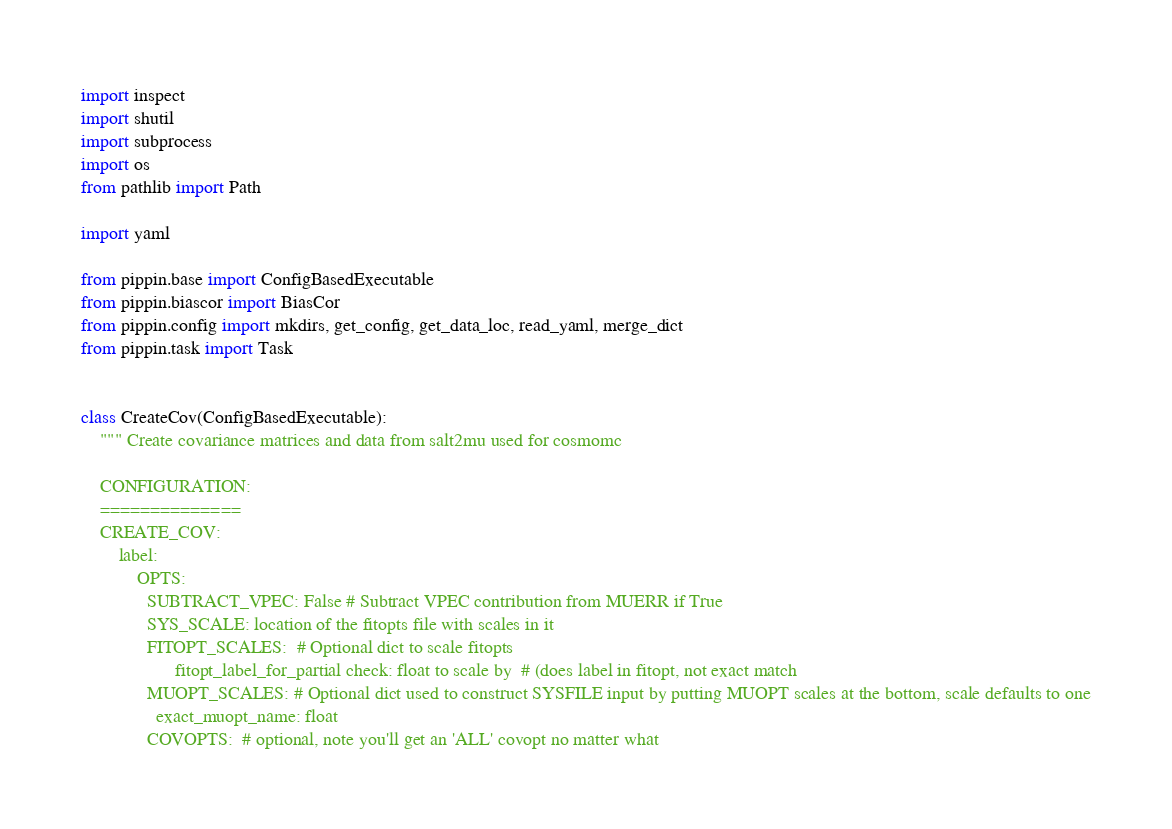<code> <loc_0><loc_0><loc_500><loc_500><_Python_>import inspect
import shutil
import subprocess
import os
from pathlib import Path

import yaml

from pippin.base import ConfigBasedExecutable
from pippin.biascor import BiasCor
from pippin.config import mkdirs, get_config, get_data_loc, read_yaml, merge_dict
from pippin.task import Task


class CreateCov(ConfigBasedExecutable):
    """ Create covariance matrices and data from salt2mu used for cosmomc

    CONFIGURATION:
    ==============
    CREATE_COV:
        label:
            OPTS:
              SUBTRACT_VPEC: False # Subtract VPEC contribution from MUERR if True
              SYS_SCALE: location of the fitopts file with scales in it
              FITOPT_SCALES:  # Optional dict to scale fitopts
                    fitopt_label_for_partial check: float to scale by  # (does label in fitopt, not exact match
              MUOPT_SCALES: # Optional dict used to construct SYSFILE input by putting MUOPT scales at the bottom, scale defaults to one
                exact_muopt_name: float
              COVOPTS:  # optional, note you'll get an 'ALL' covopt no matter what</code> 